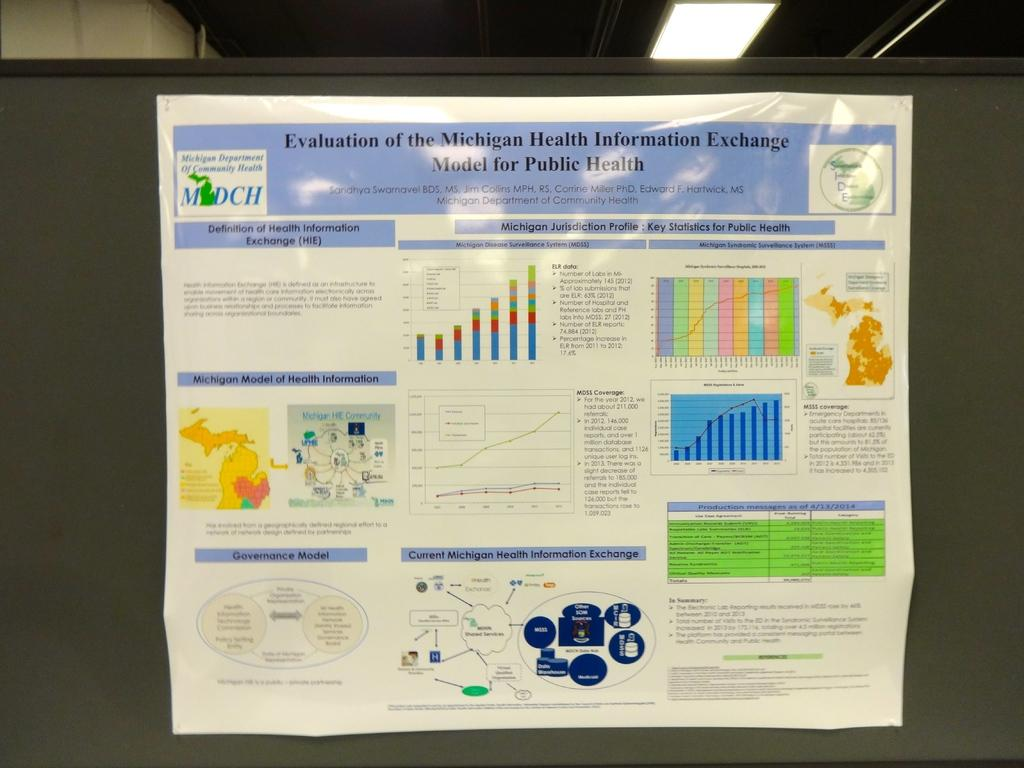<image>
Describe the image concisely. An infographic about the Michigan Health Information Exchange. 